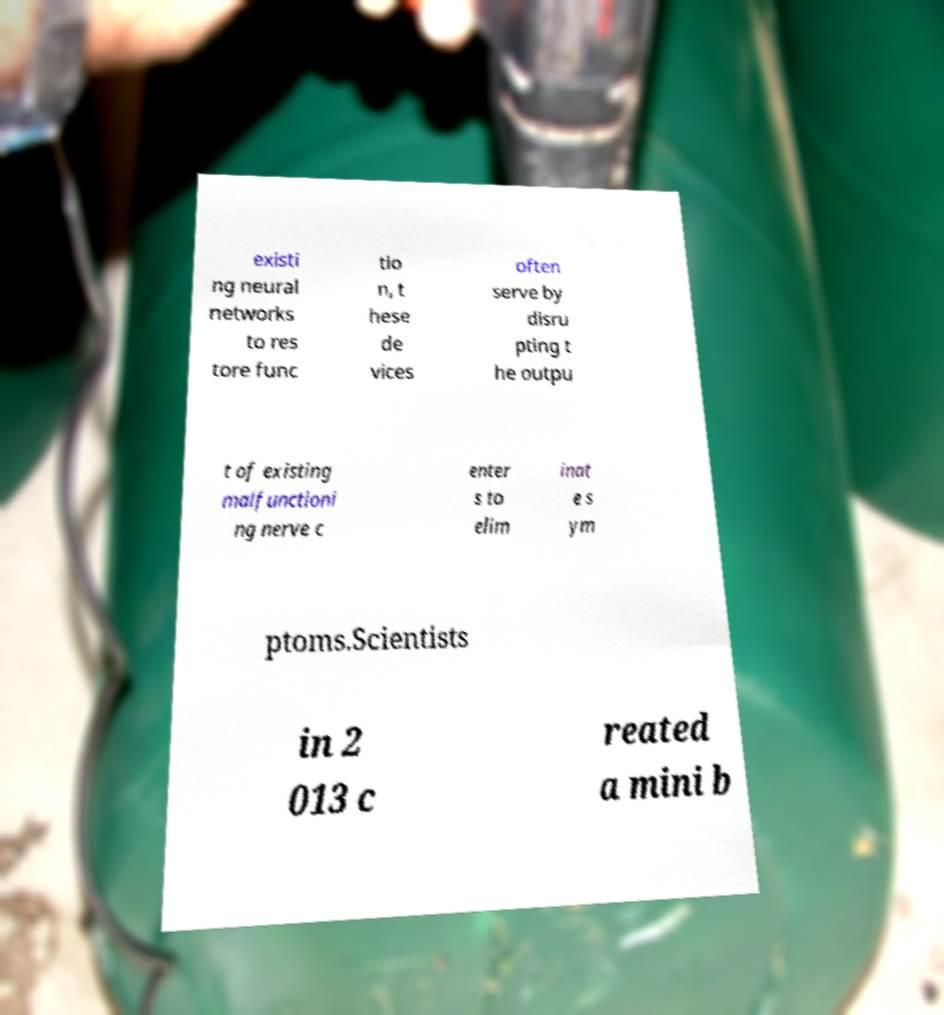What messages or text are displayed in this image? I need them in a readable, typed format. existi ng neural networks to res tore func tio n, t hese de vices often serve by disru pting t he outpu t of existing malfunctioni ng nerve c enter s to elim inat e s ym ptoms.Scientists in 2 013 c reated a mini b 